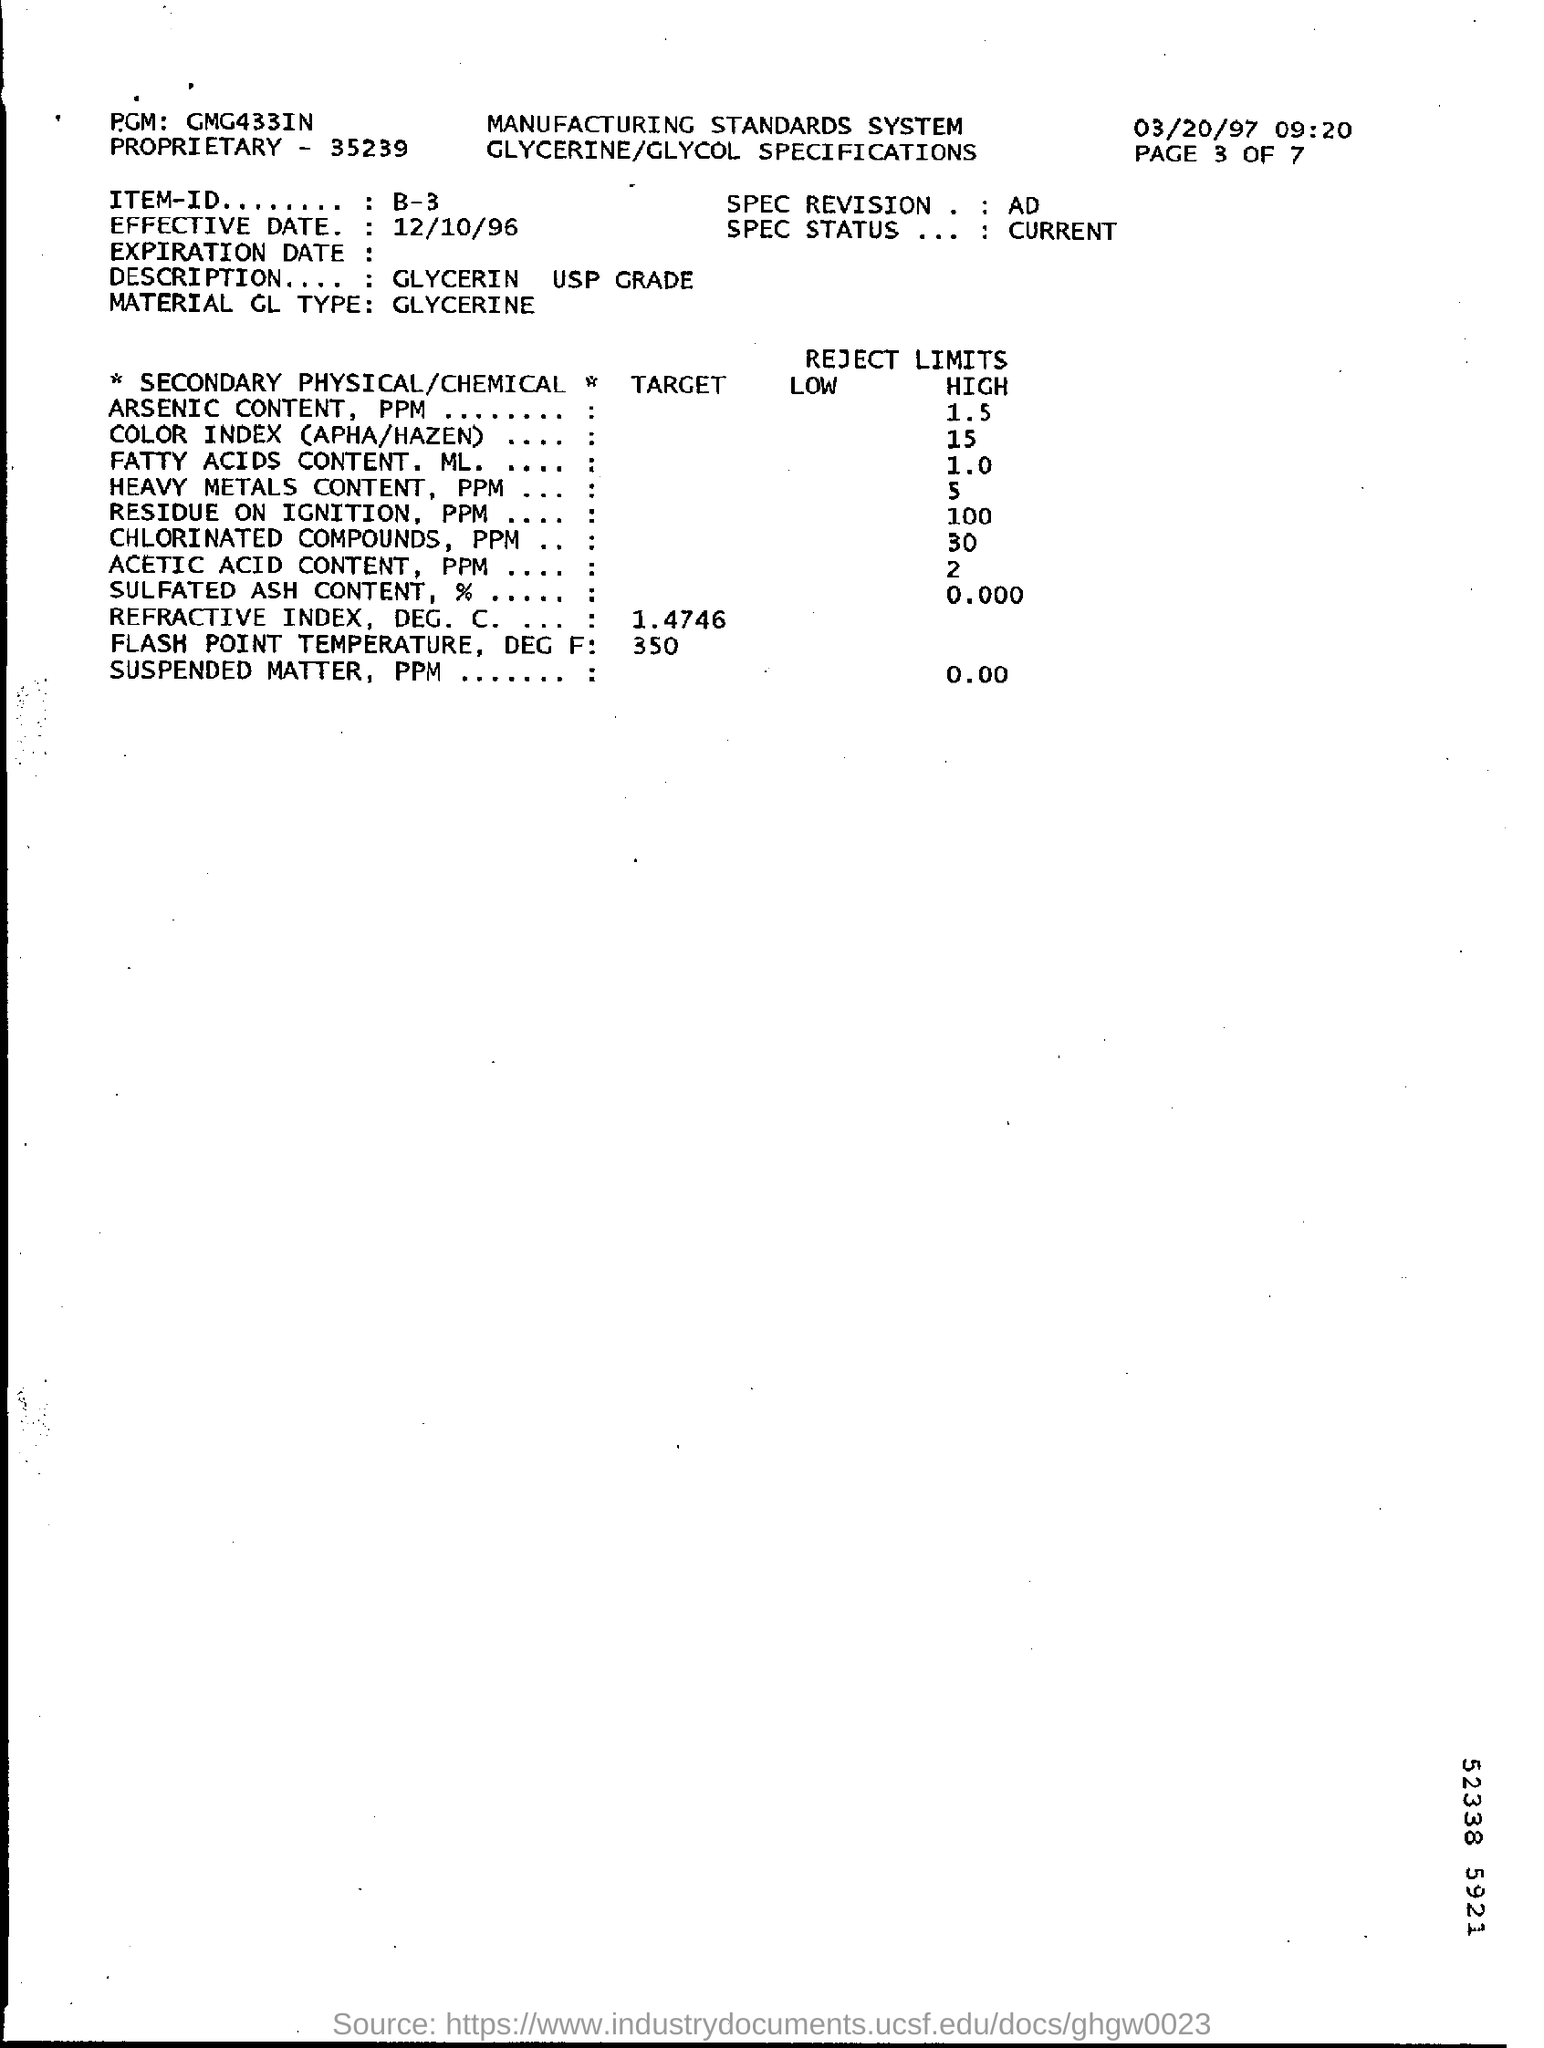What is the PGM mentioned?
Provide a short and direct response. GMG433IN. What is the ITEM-ID mentioned?
Give a very brief answer. B-3. What is the Effective Date mentioned?
Keep it short and to the point. 12/10/96. What is the description mentioned?
Your response must be concise. Glycerin USP Grade. 